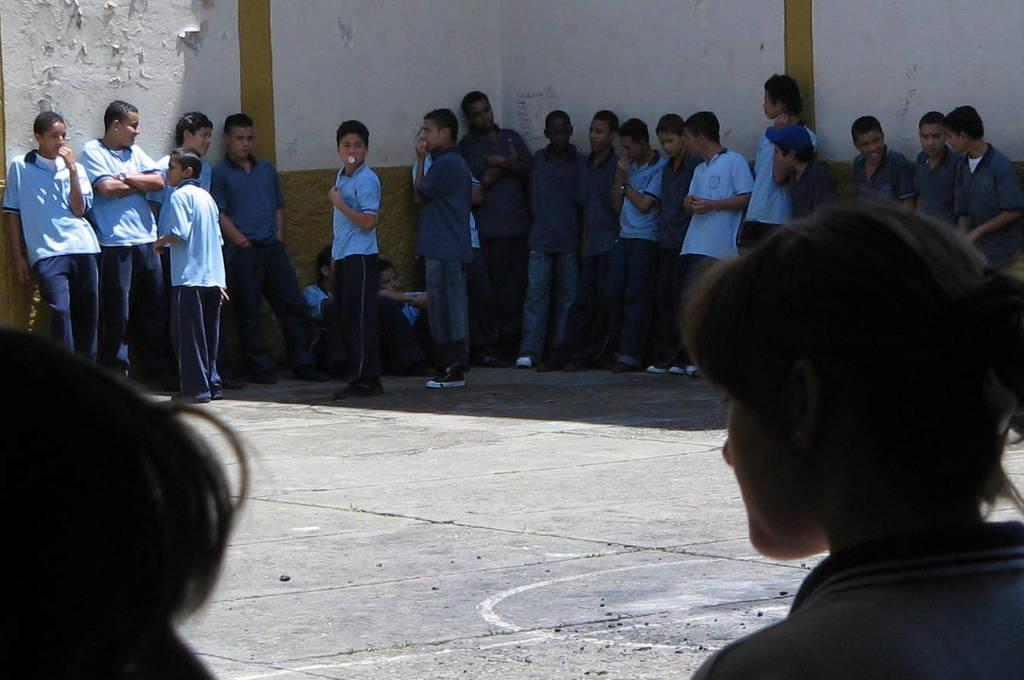What is happening in the foreground of the image? In the foreground of the image, there are persons standing near a wall and some persons sitting on the ground. Can you describe the setting of the image? The setting appears to be a school playground. What color is the crayon being used by the person sitting on the ground? There is no crayon present in the image; the persons are sitting on the ground without any visible drawing or coloring materials. 